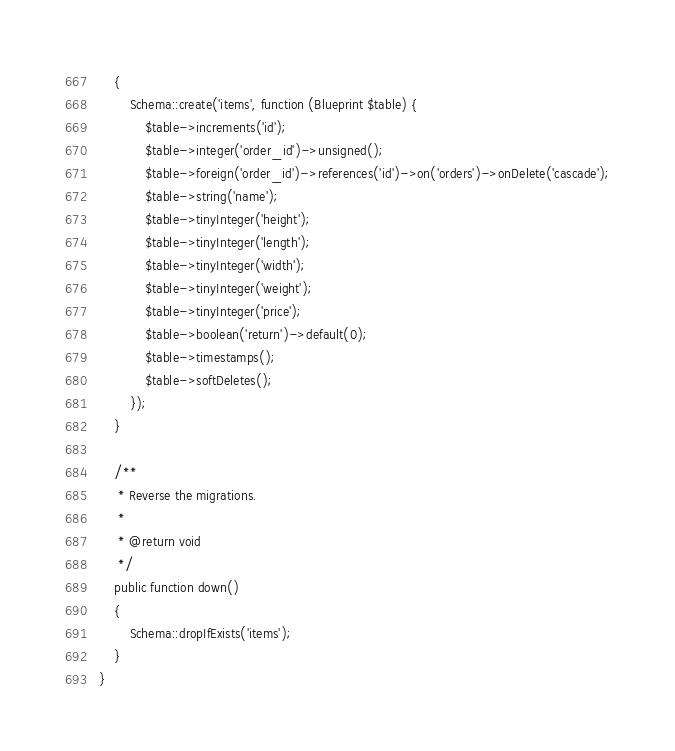<code> <loc_0><loc_0><loc_500><loc_500><_PHP_>    {
        Schema::create('items', function (Blueprint $table) {
            $table->increments('id');
            $table->integer('order_id')->unsigned();
            $table->foreign('order_id')->references('id')->on('orders')->onDelete('cascade');
            $table->string('name');
            $table->tinyInteger('height');
            $table->tinyInteger('length');
            $table->tinyInteger('width');
            $table->tinyInteger('weight');
            $table->tinyInteger('price');
            $table->boolean('return')->default(0);
            $table->timestamps();
            $table->softDeletes(); 
        });
    }

    /**
     * Reverse the migrations.
     *
     * @return void
     */
    public function down()
    {
        Schema::dropIfExists('items');
    }
}
</code> 